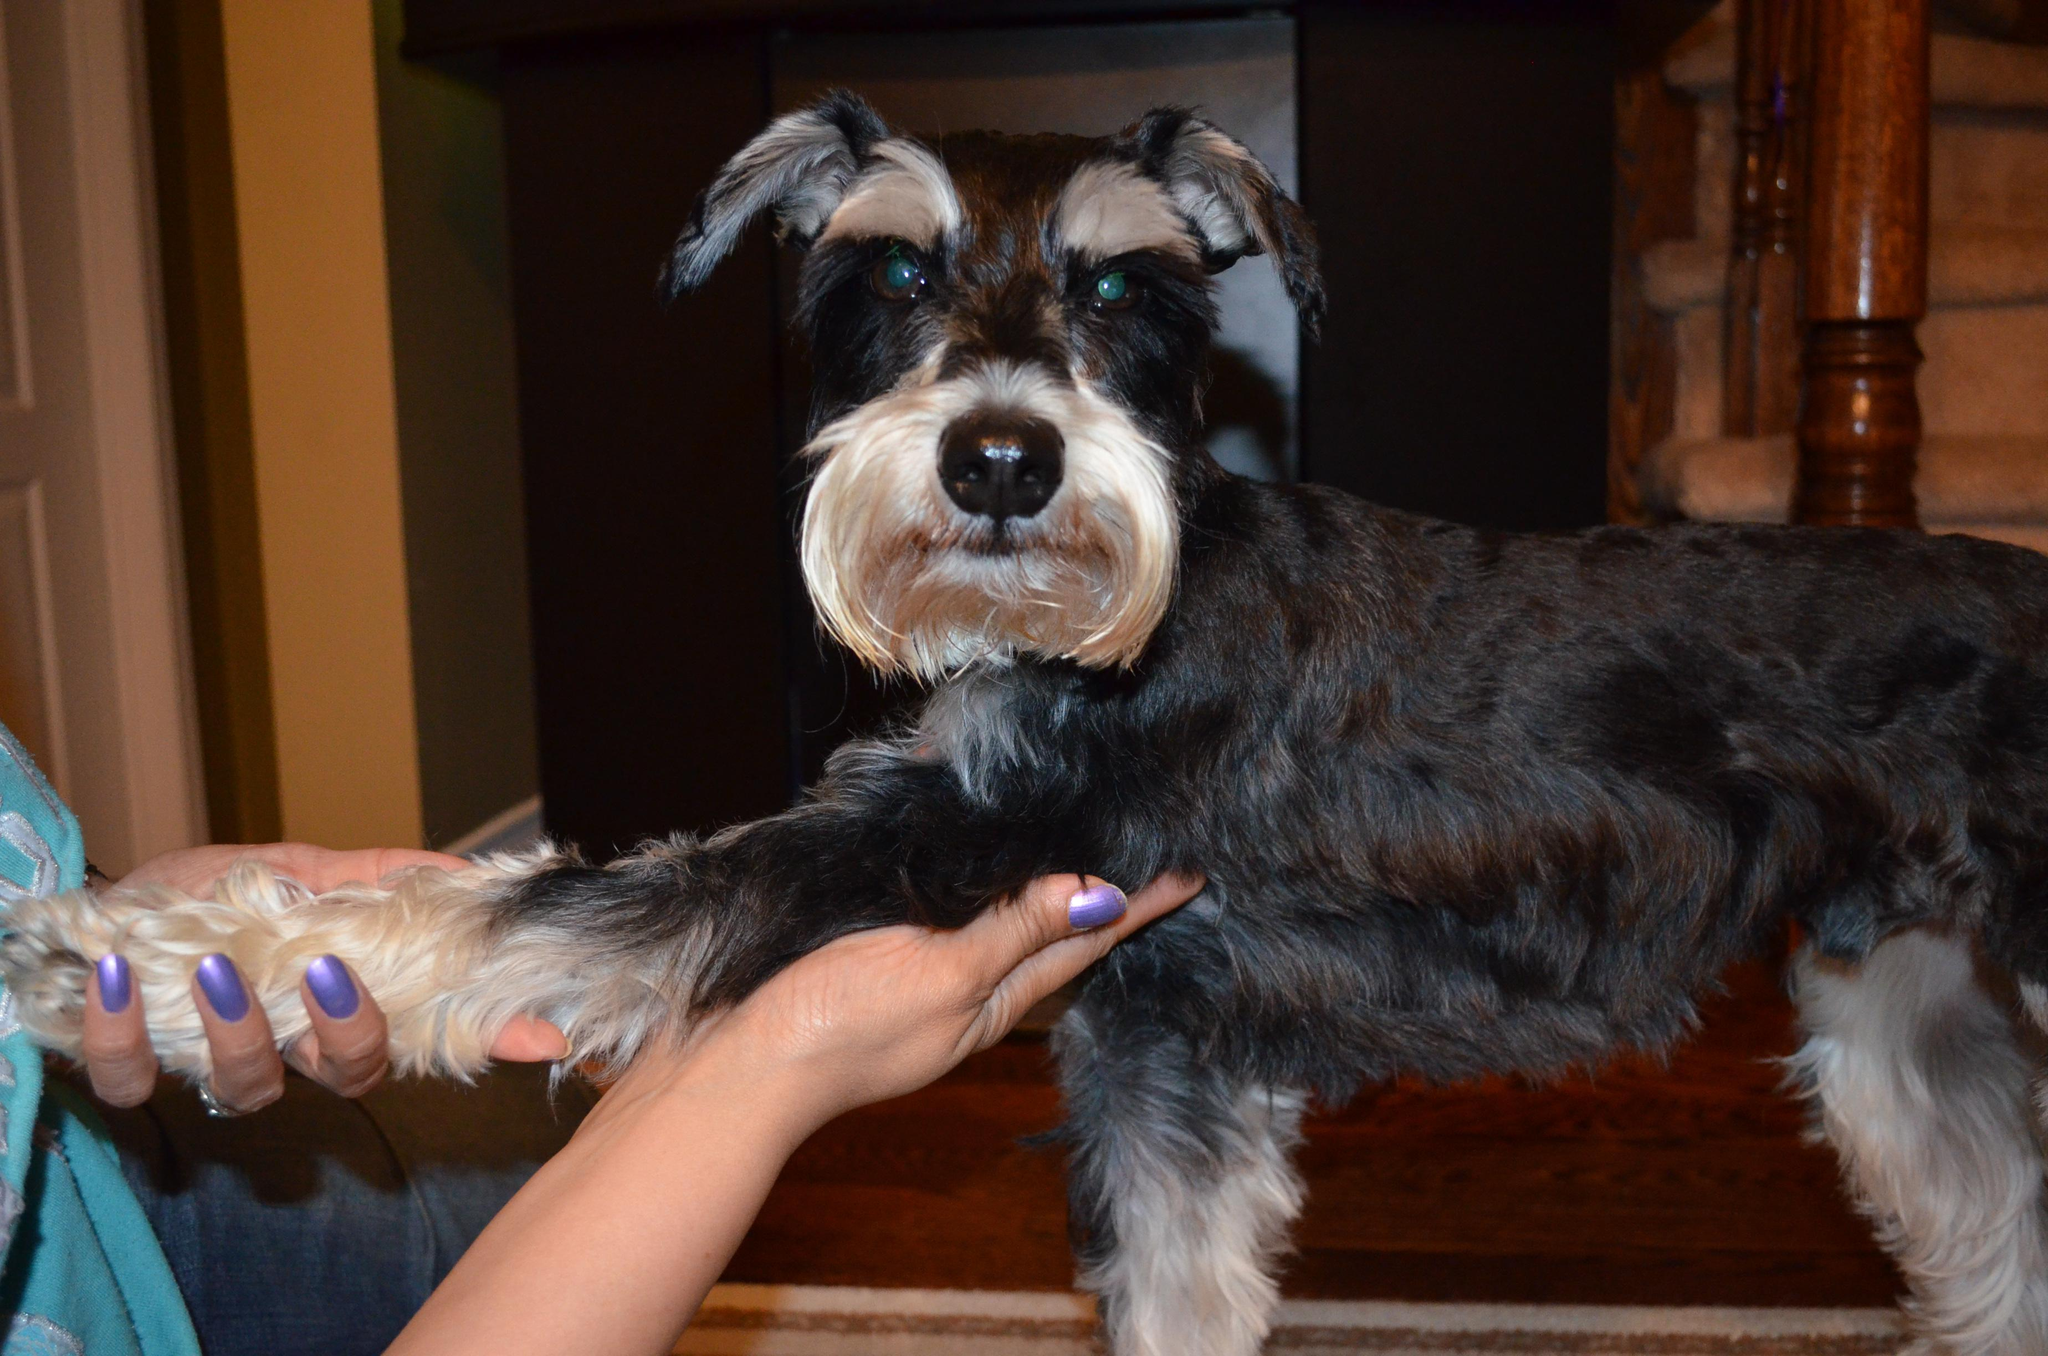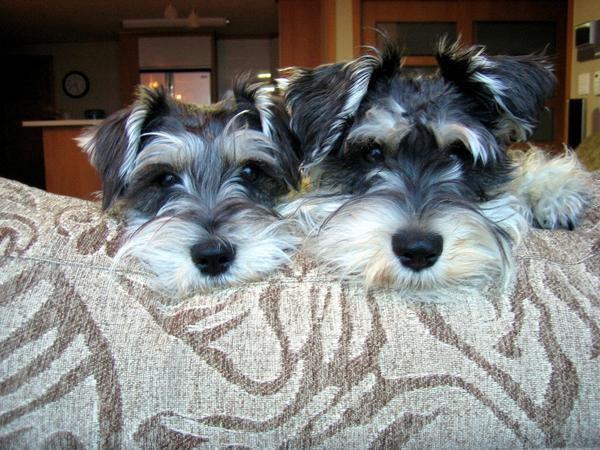The first image is the image on the left, the second image is the image on the right. Evaluate the accuracy of this statement regarding the images: "An image shows at least one schnauzer dog wearing something bright red.". Is it true? Answer yes or no. No. The first image is the image on the left, the second image is the image on the right. For the images displayed, is the sentence "One dog has a red collar in the image on the left." factually correct? Answer yes or no. No. 